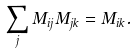<formula> <loc_0><loc_0><loc_500><loc_500>\sum _ { j } M _ { i j } M _ { j k } = M _ { i k } .</formula> 